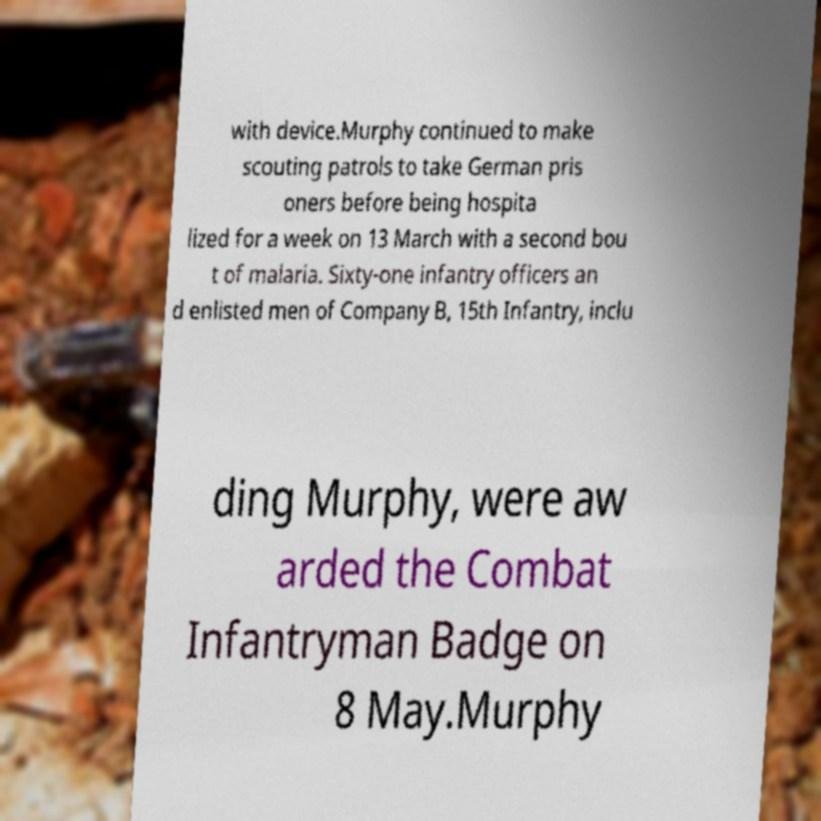For documentation purposes, I need the text within this image transcribed. Could you provide that? with device.Murphy continued to make scouting patrols to take German pris oners before being hospita lized for a week on 13 March with a second bou t of malaria. Sixty-one infantry officers an d enlisted men of Company B, 15th Infantry, inclu ding Murphy, were aw arded the Combat Infantryman Badge on 8 May.Murphy 